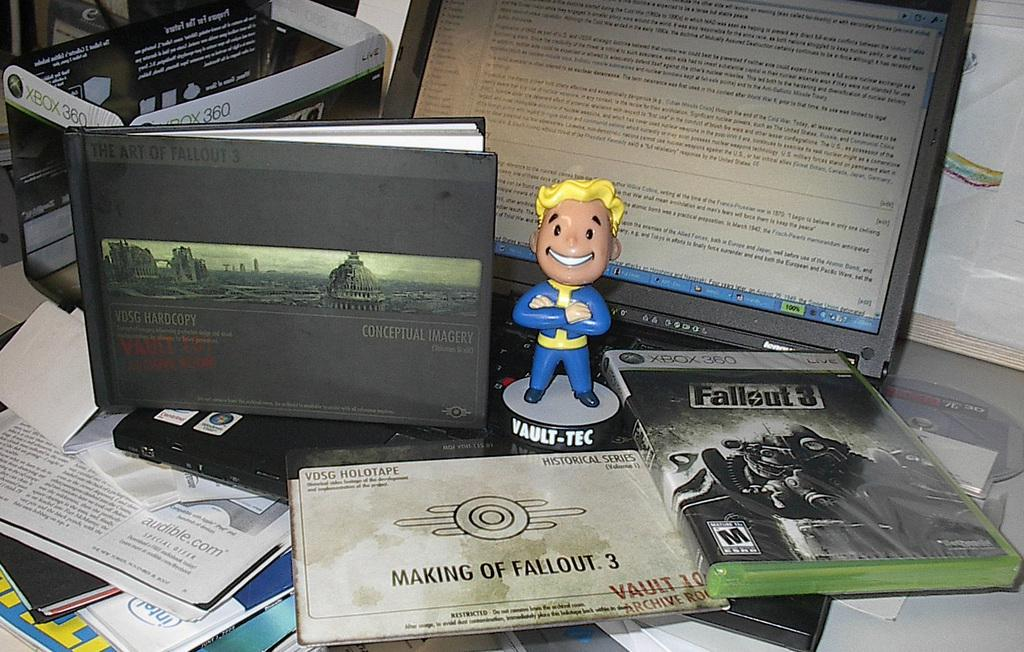Provide a one-sentence caption for the provided image. A small figurine of a super hero reading  VAULT-TEC on the base. 